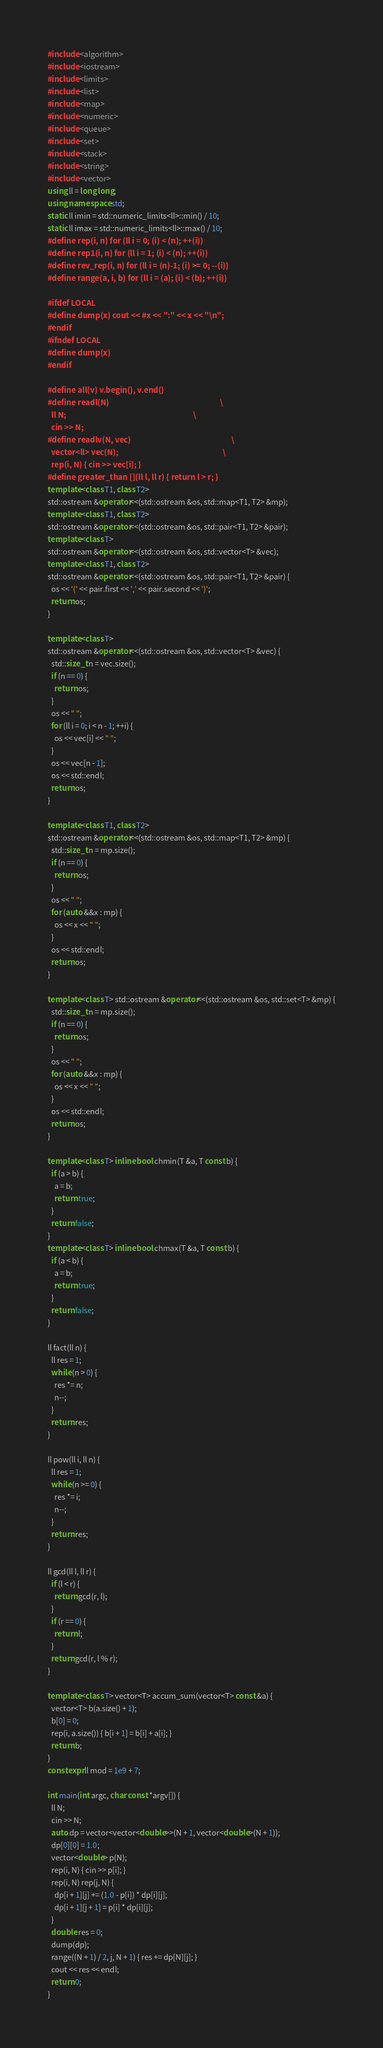<code> <loc_0><loc_0><loc_500><loc_500><_C++_>#include <algorithm>
#include <iostream>
#include <limits>
#include <list>
#include <map>
#include <numeric>
#include <queue>
#include <set>
#include <stack>
#include <string>
#include <vector>
using ll = long long;
using namespace std;
static ll imin = std::numeric_limits<ll>::min() / 10;
static ll imax = std::numeric_limits<ll>::max() / 10;
#define rep(i, n) for (ll i = 0; (i) < (n); ++(i))
#define rep1(i, n) for (ll i = 1; (i) < (n); ++(i))
#define rev_rep(i, n) for (ll i = (n)-1; (i) >= 0; --(i))
#define range(a, i, b) for (ll i = (a); (i) < (b); ++(i))

#ifdef LOCAL
#define dump(x) cout << #x << ":" << x << "\n";
#endif
#ifndef LOCAL
#define dump(x)
#endif

#define all(v) v.begin(), v.end()
#define readl(N)                                                               \
  ll N;                                                                        \
  cin >> N;
#define readlv(N, vec)                                                         \
  vector<ll> vec(N);                                                           \
  rep(i, N) { cin >> vec[i]; }
#define greater_than [](ll l, ll r) { return l > r; }
template <class T1, class T2>
std::ostream &operator<<(std::ostream &os, std::map<T1, T2> &mp);
template <class T1, class T2>
std::ostream &operator<<(std::ostream &os, std::pair<T1, T2> &pair);
template <class T>
std::ostream &operator<<(std::ostream &os, std::vector<T> &vec);
template <class T1, class T2>
std::ostream &operator<<(std::ostream &os, std::pair<T1, T2> &pair) {
  os << '(' << pair.first << ',' << pair.second << ')';
  return os;
}

template <class T>
std::ostream &operator<<(std::ostream &os, std::vector<T> &vec) {
  std::size_t n = vec.size();
  if (n == 0) {
    return os;
  }
  os << " ";
  for (ll i = 0; i < n - 1; ++i) {
    os << vec[i] << " ";
  }
  os << vec[n - 1];
  os << std::endl;
  return os;
}

template <class T1, class T2>
std::ostream &operator<<(std::ostream &os, std::map<T1, T2> &mp) {
  std::size_t n = mp.size();
  if (n == 0) {
    return os;
  }
  os << " ";
  for (auto &&x : mp) {
    os << x << " ";
  }
  os << std::endl;
  return os;
}

template <class T> std::ostream &operator<<(std::ostream &os, std::set<T> &mp) {
  std::size_t n = mp.size();
  if (n == 0) {
    return os;
  }
  os << " ";
  for (auto &&x : mp) {
    os << x << " ";
  }
  os << std::endl;
  return os;
}

template <class T> inline bool chmin(T &a, T const b) {
  if (a > b) {
    a = b;
    return true;
  }
  return false;
}
template <class T> inline bool chmax(T &a, T const b) {
  if (a < b) {
    a = b;
    return true;
  }
  return false;
}

ll fact(ll n) {
  ll res = 1;
  while (n > 0) {
    res *= n;
    n--;
  }
  return res;
}

ll pow(ll i, ll n) {
  ll res = 1;
  while (n >= 0) {
    res *= i;
    n--;
  }
  return res;
}

ll gcd(ll l, ll r) {
  if (l < r) {
    return gcd(r, l);
  }
  if (r == 0) {
    return l;
  }
  return gcd(r, l % r);
}

template <class T> vector<T> accum_sum(vector<T> const &a) {
  vector<T> b(a.size() + 1);
  b[0] = 0;
  rep(i, a.size()) { b[i + 1] = b[i] + a[i]; }
  return b;
}
constexpr ll mod = 1e9 + 7;

int main(int argc, char const *argv[]) {
  ll N;
  cin >> N;
  auto dp = vector<vector<double>>(N + 1, vector<double>(N + 1));
  dp[0][0] = 1.0;
  vector<double> p(N);
  rep(i, N) { cin >> p[i]; }
  rep(i, N) rep(j, N) {
    dp[i + 1][j] += (1.0 - p[i]) * dp[i][j];
    dp[i + 1][j + 1] = p[i] * dp[i][j];
  }
  double res = 0;
  dump(dp);
  range((N + 1) / 2, j, N + 1) { res += dp[N][j]; }
  cout << res << endl;
  return 0;
}
</code> 